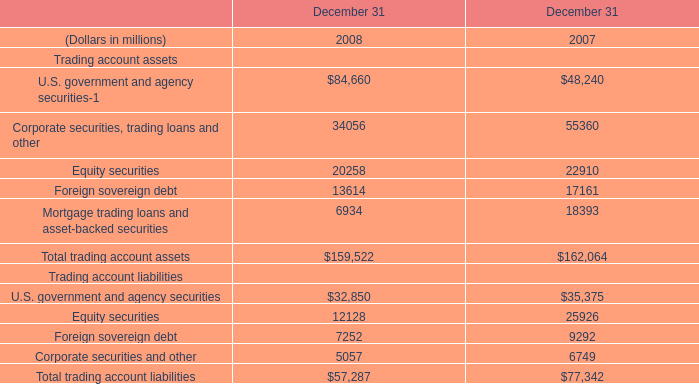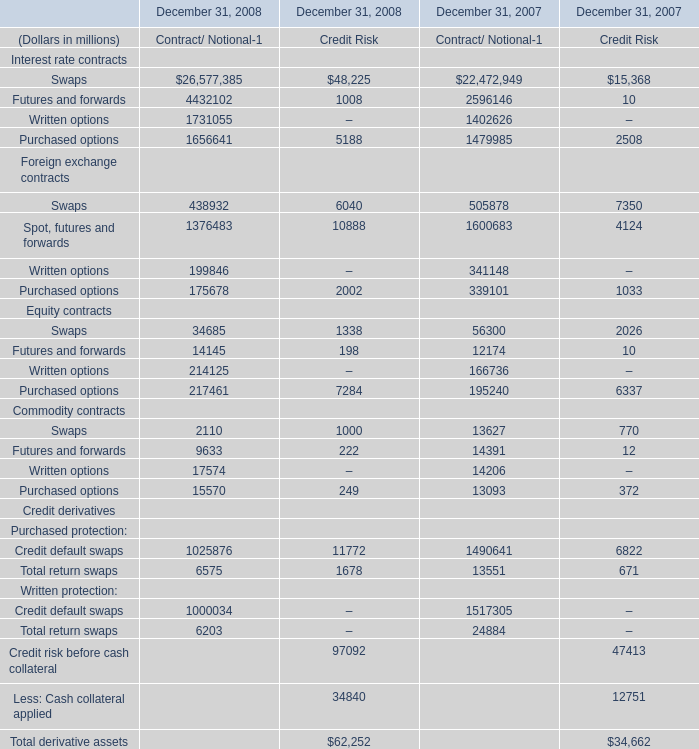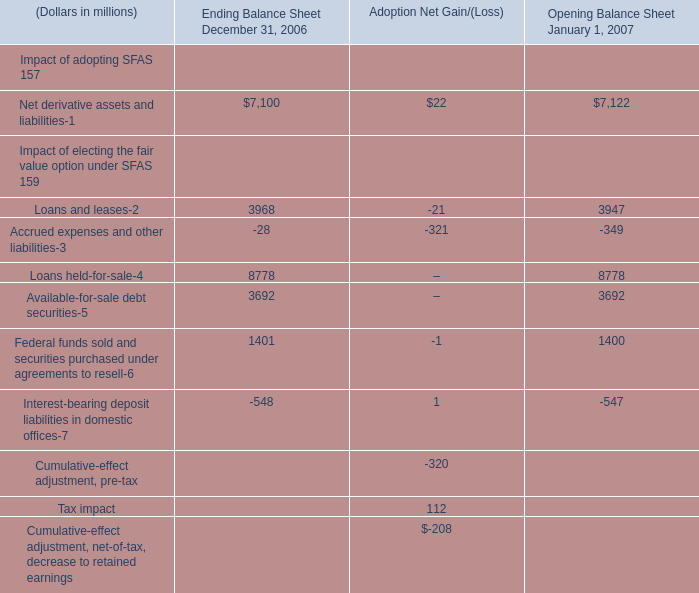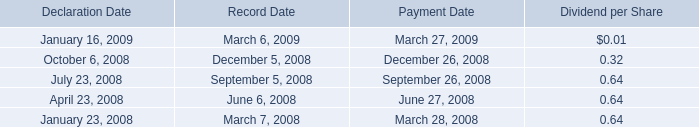In which years is Futures and forwards greater than Written options for Contract/ Notional-？ 
Answer: 2008;2007. 